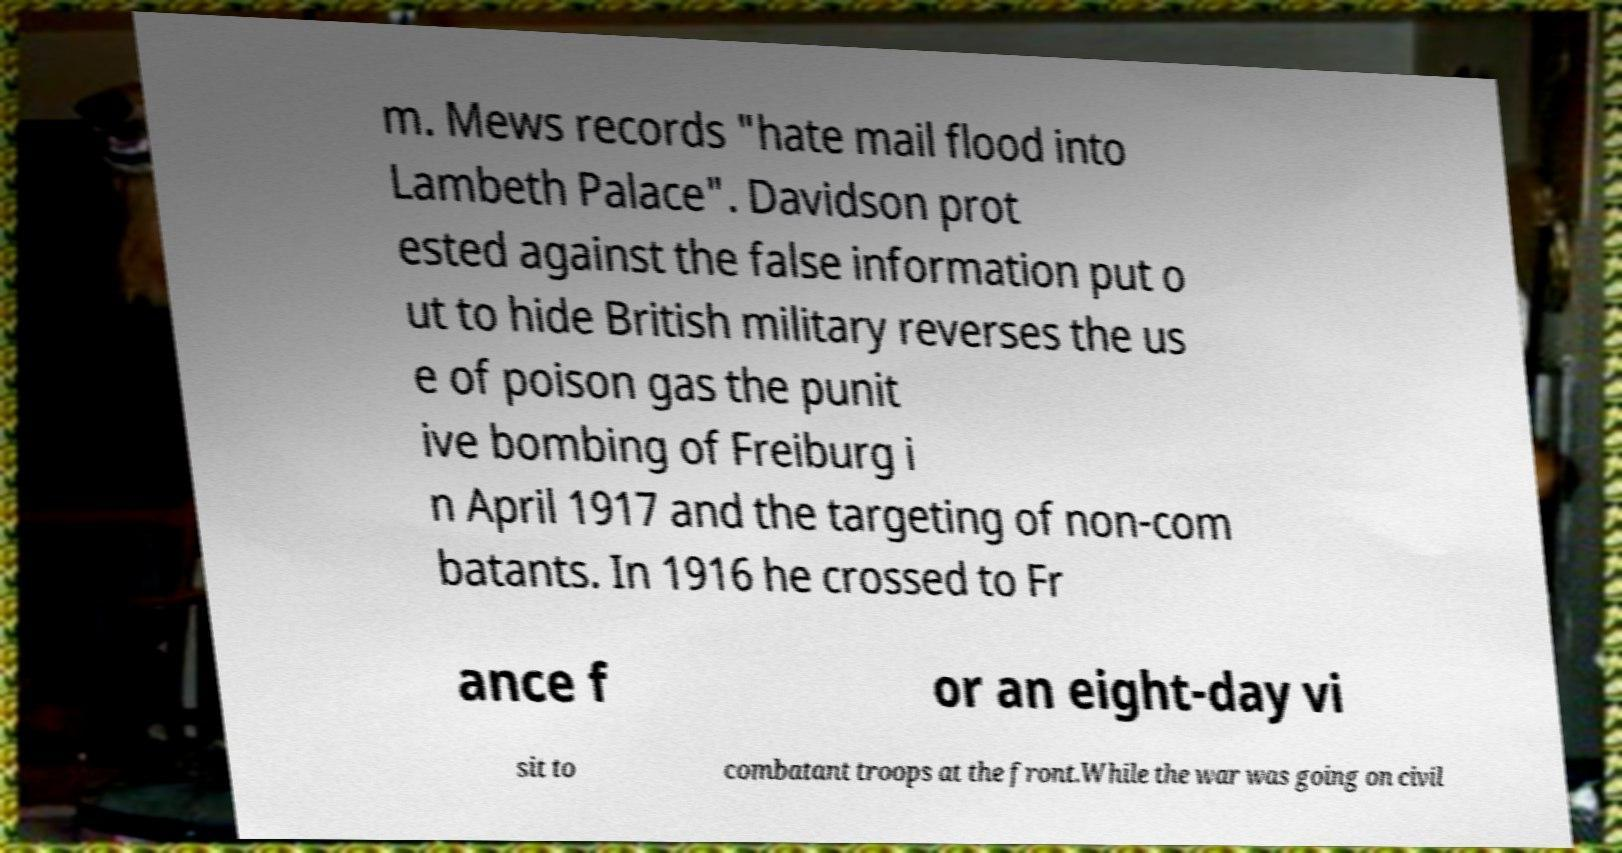Could you assist in decoding the text presented in this image and type it out clearly? m. Mews records "hate mail flood into Lambeth Palace". Davidson prot ested against the false information put o ut to hide British military reverses the us e of poison gas the punit ive bombing of Freiburg i n April 1917 and the targeting of non-com batants. In 1916 he crossed to Fr ance f or an eight-day vi sit to combatant troops at the front.While the war was going on civil 